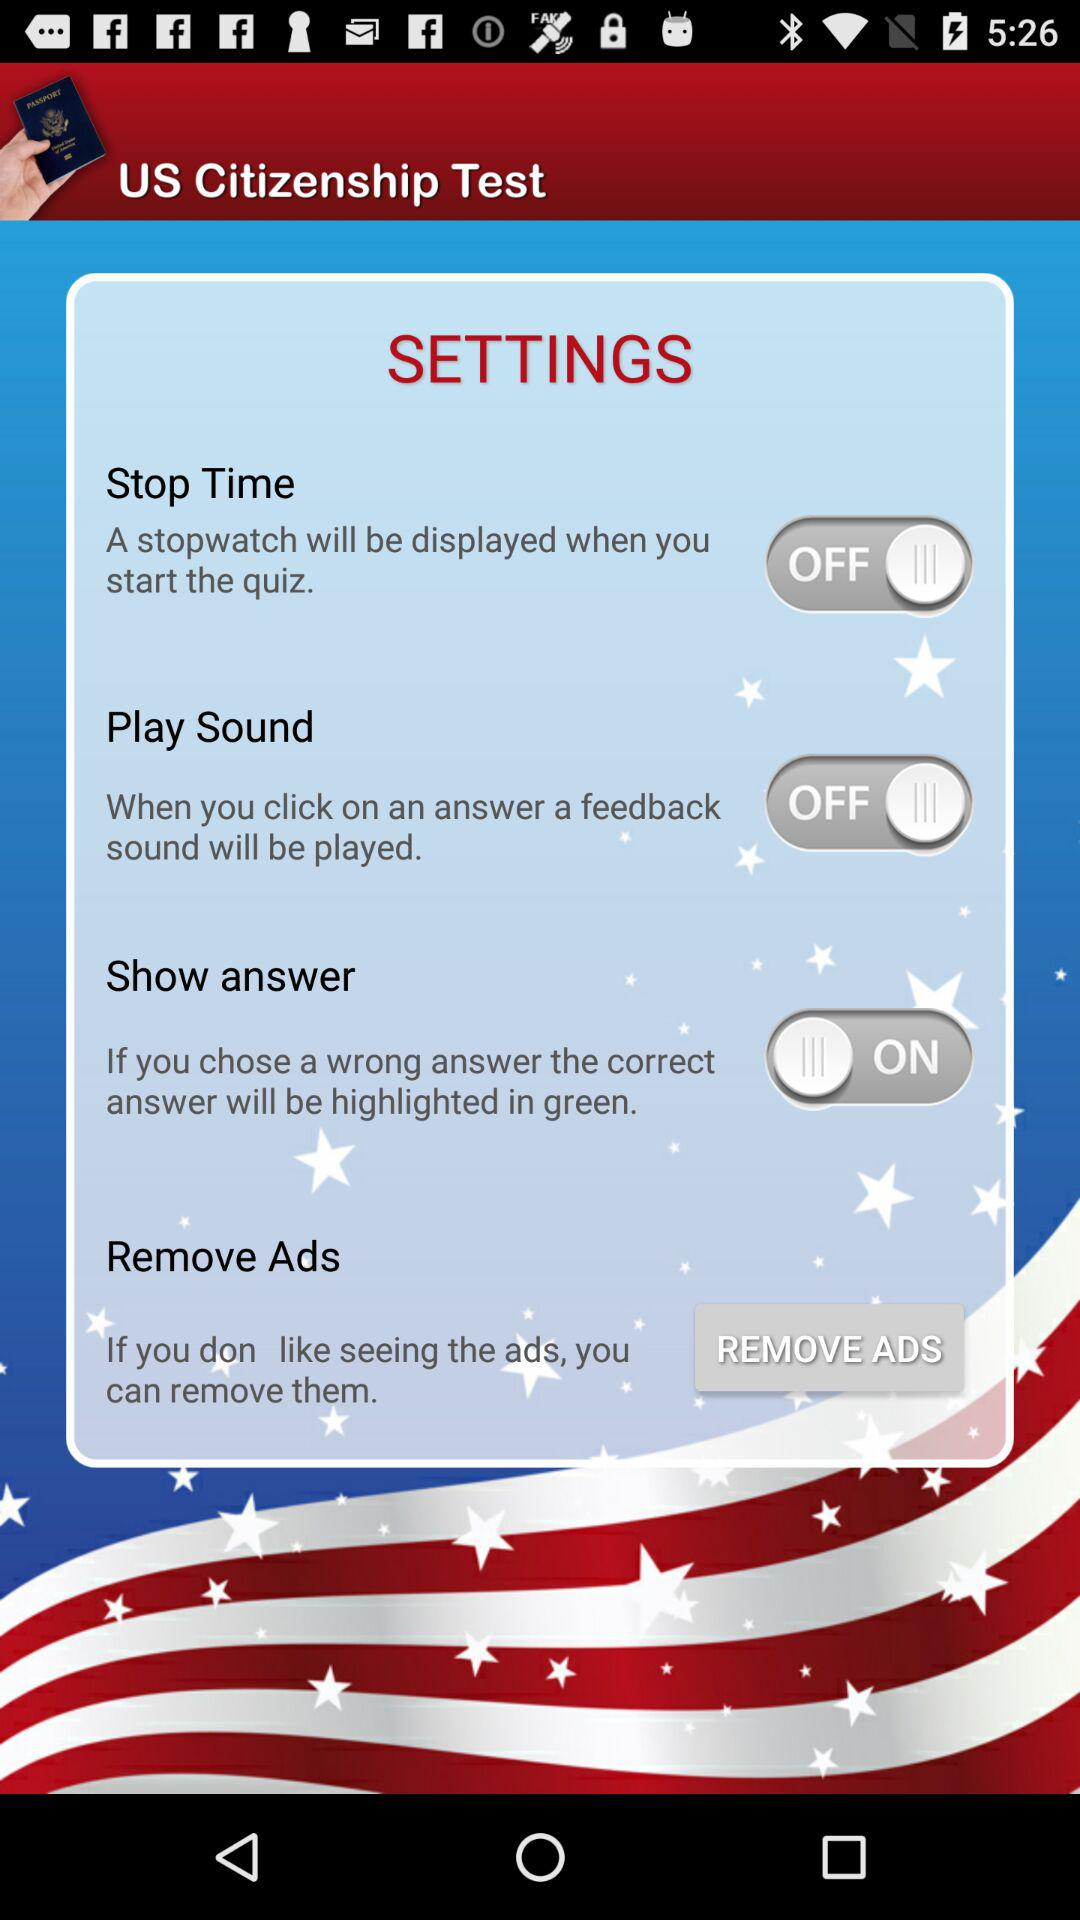How many switches are in the settings screen?
Answer the question using a single word or phrase. 3 